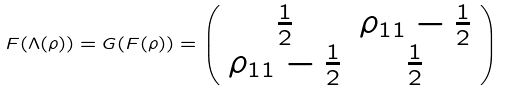<formula> <loc_0><loc_0><loc_500><loc_500>F ( \Lambda ( \rho ) ) = G ( F ( \rho ) ) = \left ( \begin{array} { c c } \frac { 1 } { 2 } & \rho _ { 1 1 } - \frac { 1 } { 2 } \\ \rho _ { 1 1 } - \frac { 1 } { 2 } & \frac { 1 } { 2 } \end{array} \right )</formula> 